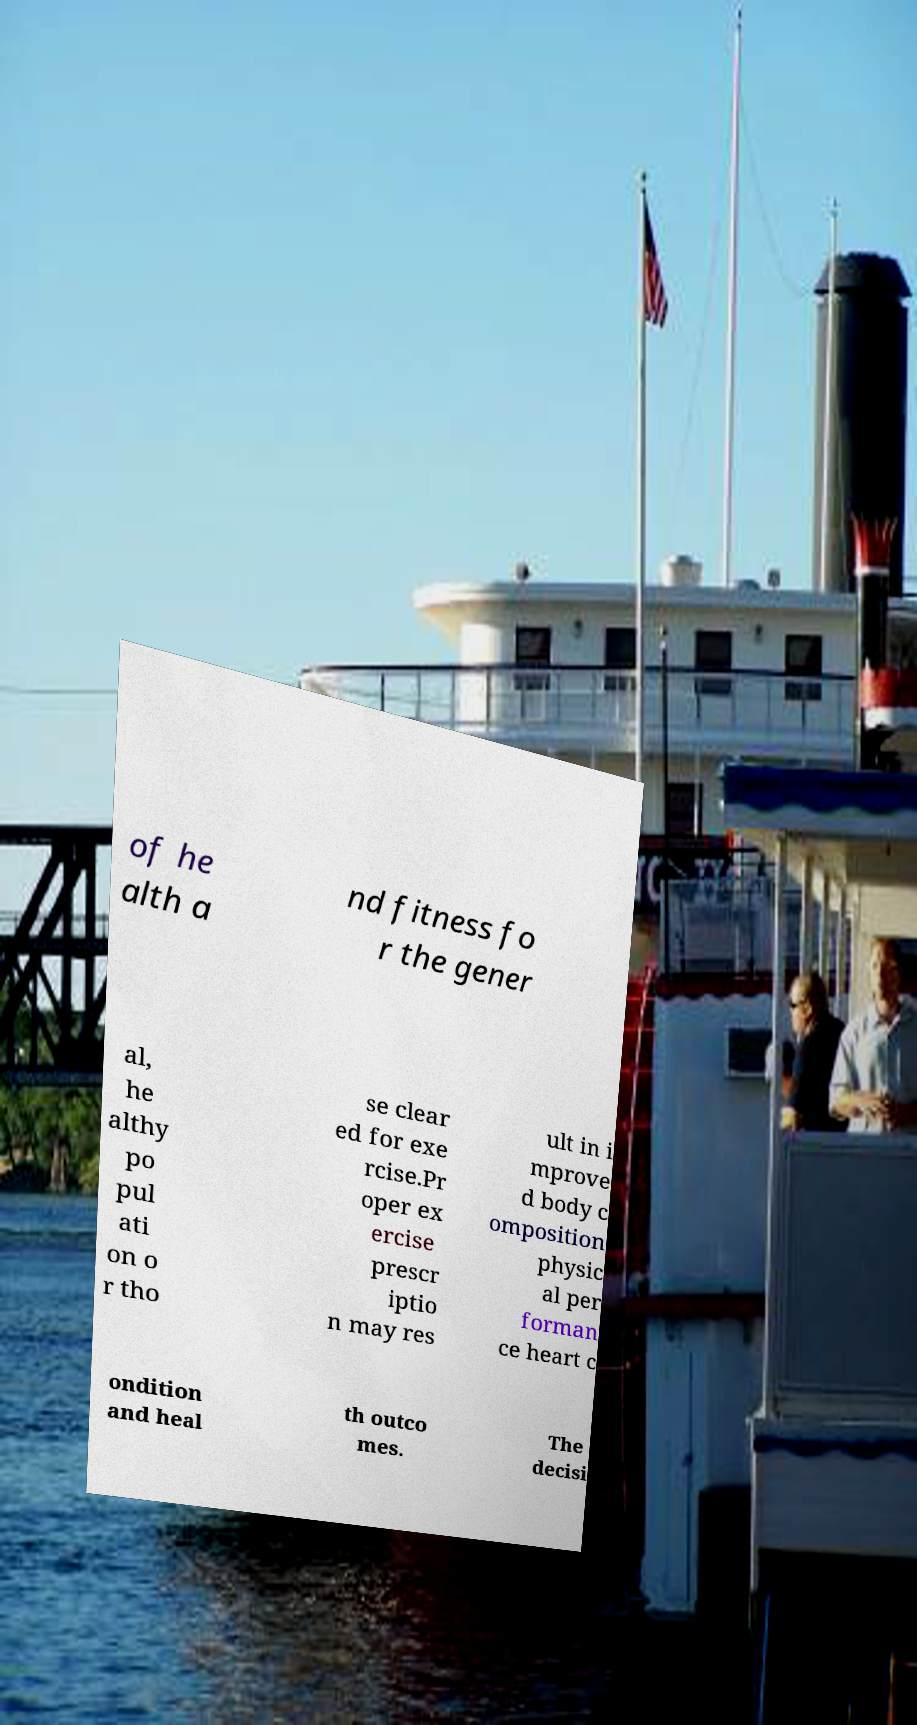Please read and relay the text visible in this image. What does it say? of he alth a nd fitness fo r the gener al, he althy po pul ati on o r tho se clear ed for exe rcise.Pr oper ex ercise prescr iptio n may res ult in i mprove d body c omposition physic al per forman ce heart c ondition and heal th outco mes. The decisi 